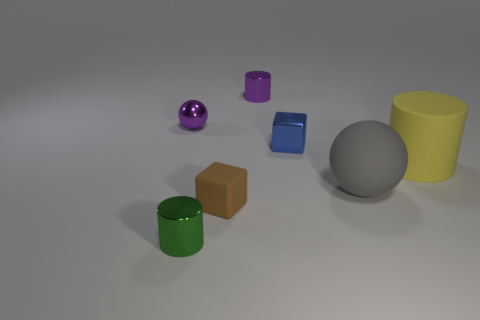Subtract all metallic cylinders. How many cylinders are left? 1 Subtract 2 spheres. How many spheres are left? 0 Subtract all spheres. How many objects are left? 5 Subtract all purple cylinders. How many cylinders are left? 2 Add 5 small purple objects. How many small purple objects are left? 7 Add 5 tiny metallic blocks. How many tiny metallic blocks exist? 6 Add 1 green cylinders. How many objects exist? 8 Subtract 0 cyan spheres. How many objects are left? 7 Subtract all brown blocks. Subtract all red cylinders. How many blocks are left? 1 Subtract all gray cubes. How many blue cylinders are left? 0 